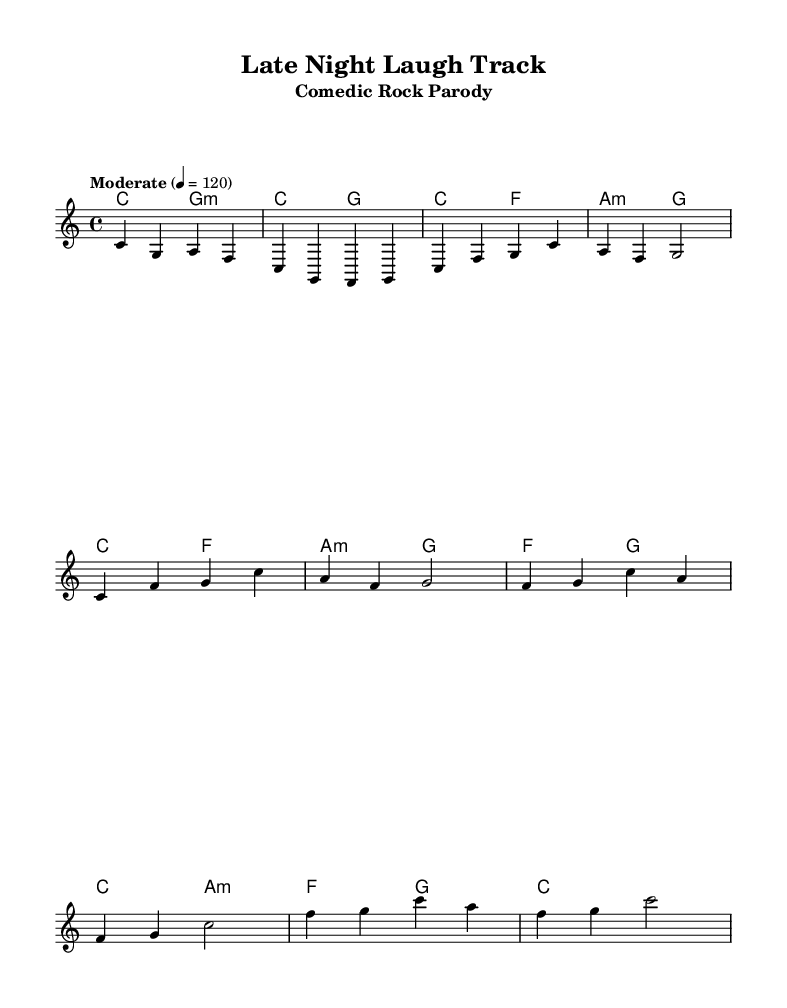What is the key signature of this music? The key signature is indicated at the beginning of the staff, showing no sharps or flats, which confirms it is C major.
Answer: C major What is the time signature of this music? The time signature is shown as 4/4, which means there are four beats in each measure and a quarter note gets one beat.
Answer: 4/4 What is the tempo marking for this piece? The tempo is indicated as "Moderate" at the beginning, with the metronome marking of 120 beats per minute.
Answer: Moderate, 120 How many measures are there in the verse section? The verse section consists of 8 measures, which can be counted by looking at the horizontal lines that separate each measure.
Answer: 8 What are the first three notes of the melody? The first three notes in the melody are displayed at the beginning of the score; these are C, G, and A, which are seen in the introduction of the sheet music.
Answer: C, G, A What chords are used in the chorus? The chords in the chorus section include F, G, C, and A minor, as shown in the chord names written above the melody line.
Answer: F, G, C, A minor How many times does the melody repeat in the chorus? The melody repeats the chorus 2 times, as shown by the layout of the lyrics and melody indicating two sections followed by a conclusion.
Answer: 2 